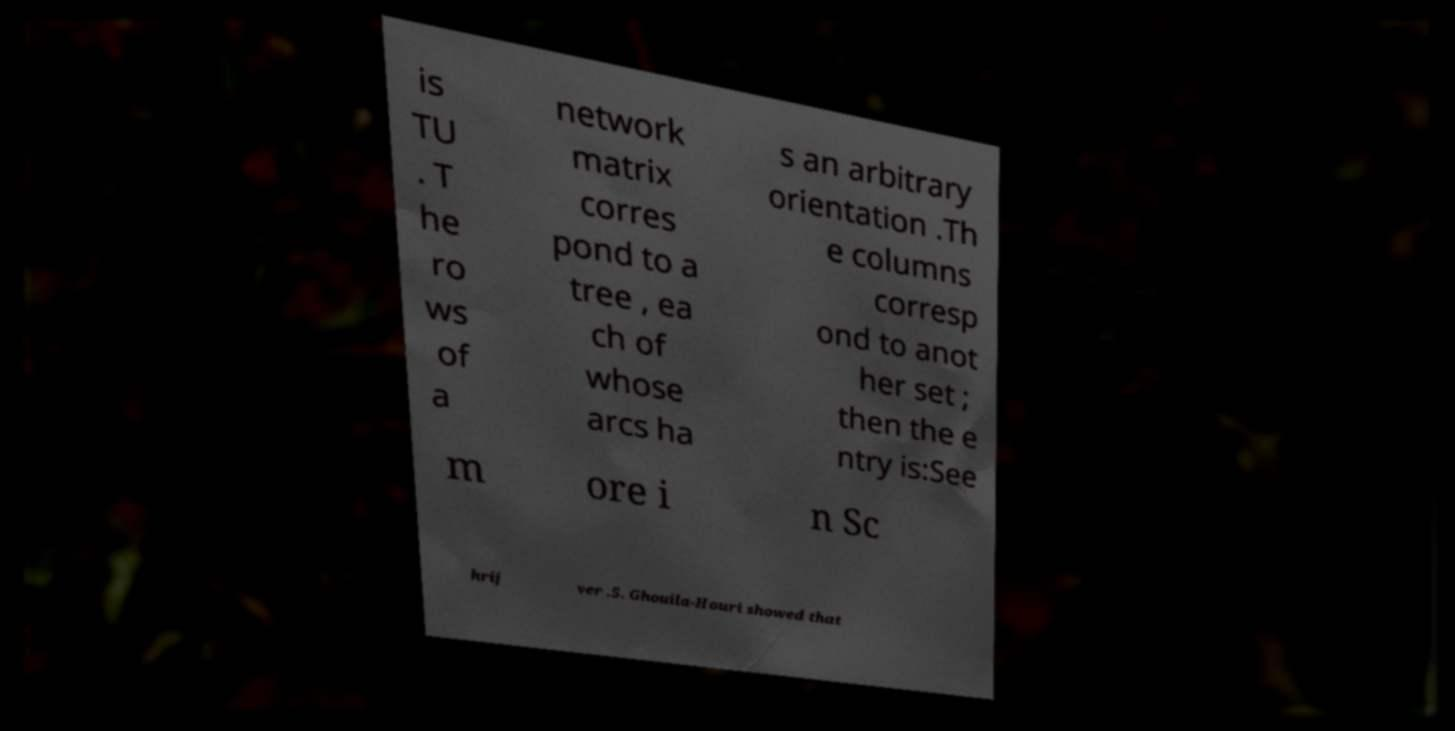Please read and relay the text visible in this image. What does it say? is TU . T he ro ws of a network matrix corres pond to a tree , ea ch of whose arcs ha s an arbitrary orientation .Th e columns corresp ond to anot her set ; then the e ntry is:See m ore i n Sc hrij ver .5. Ghouila-Houri showed that 